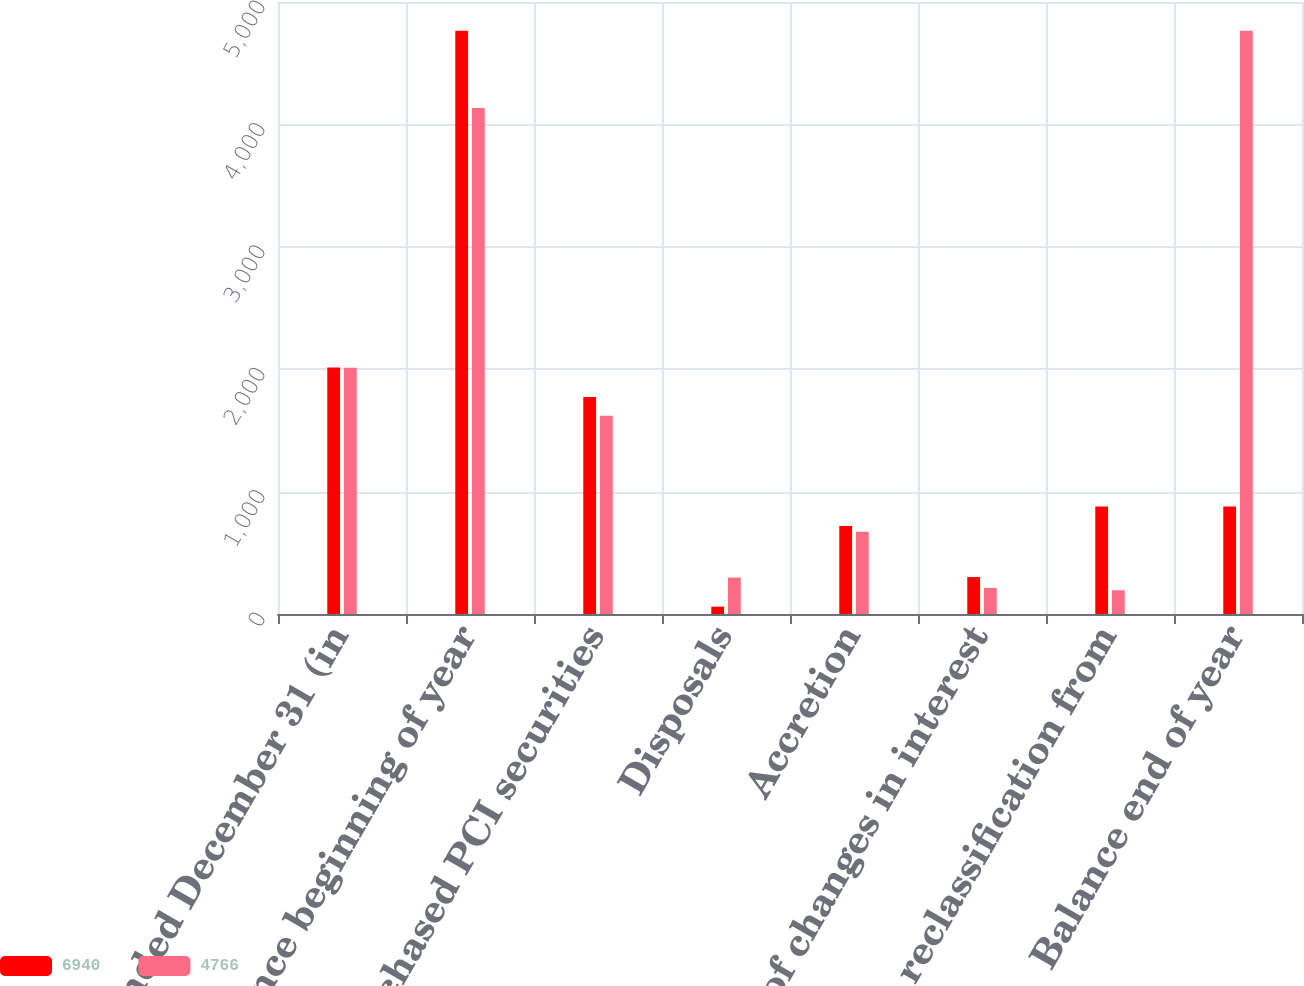Convert chart. <chart><loc_0><loc_0><loc_500><loc_500><stacked_bar_chart><ecel><fcel>Years Ended December 31 (in<fcel>Balance beginning of year<fcel>Newly purchased PCI securities<fcel>Disposals<fcel>Accretion<fcel>Effect of changes in interest<fcel>Net reclassification from<fcel>Balance end of year<nl><fcel>6940<fcel>2013<fcel>4766<fcel>1773<fcel>60<fcel>719<fcel>302<fcel>878<fcel>878<nl><fcel>4766<fcel>2012<fcel>4135<fcel>1620<fcel>298<fcel>672<fcel>213<fcel>194<fcel>4766<nl></chart> 